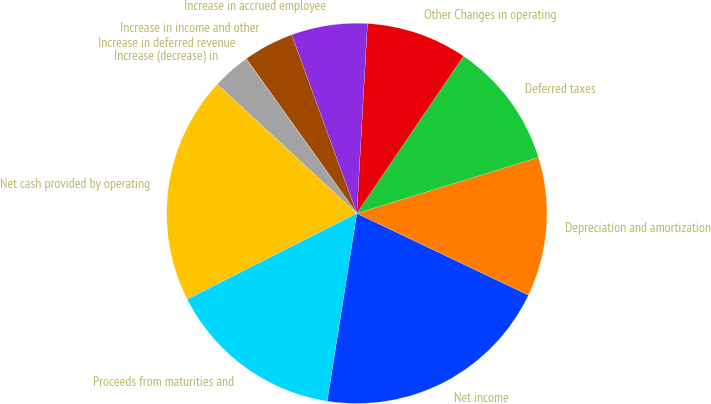<chart> <loc_0><loc_0><loc_500><loc_500><pie_chart><fcel>Net income<fcel>Depreciation and amortization<fcel>Deferred taxes<fcel>Other Changes in operating<fcel>Increase in accrued employee<fcel>Increase in income and other<fcel>Increase in deferred revenue<fcel>Increase (decrease) in<fcel>Net cash provided by operating<fcel>Proceeds from maturities and<nl><fcel>20.42%<fcel>11.83%<fcel>10.75%<fcel>8.6%<fcel>6.46%<fcel>4.31%<fcel>0.01%<fcel>3.23%<fcel>19.34%<fcel>15.05%<nl></chart> 